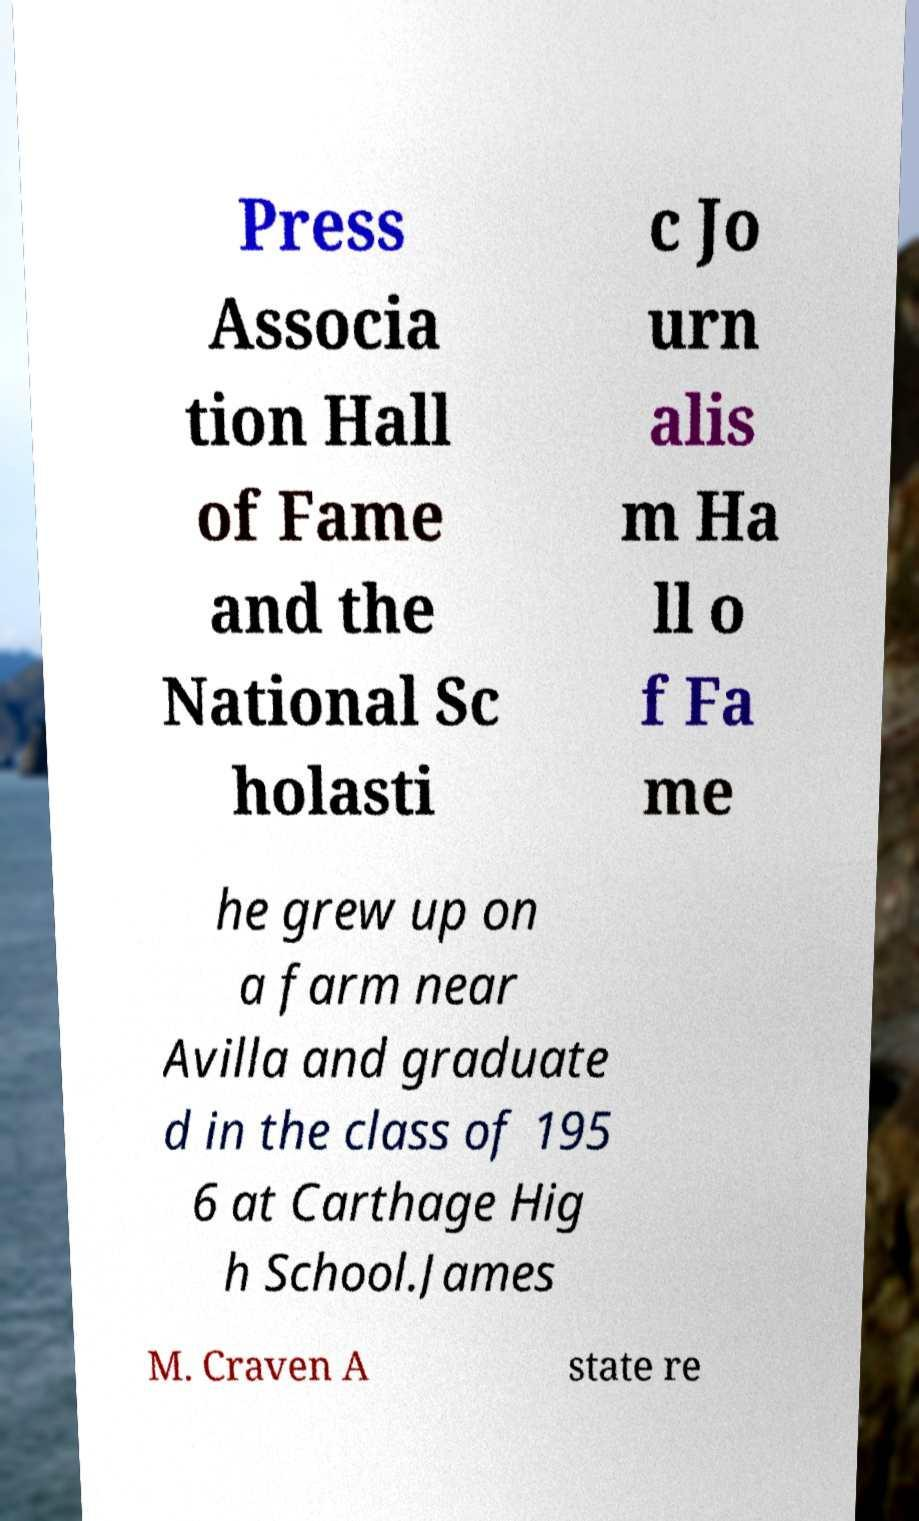Can you read and provide the text displayed in the image?This photo seems to have some interesting text. Can you extract and type it out for me? Press Associa tion Hall of Fame and the National Sc holasti c Jo urn alis m Ha ll o f Fa me he grew up on a farm near Avilla and graduate d in the class of 195 6 at Carthage Hig h School.James M. Craven A state re 